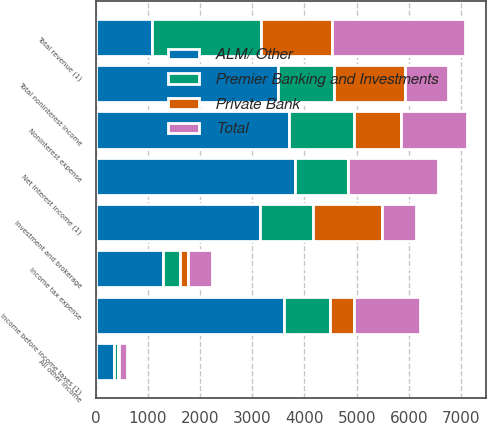Convert chart to OTSL. <chart><loc_0><loc_0><loc_500><loc_500><stacked_bar_chart><ecel><fcel>Net interest income (1)<fcel>Investment and brokerage<fcel>All other income<fcel>Total noninterest income<fcel>Total revenue (1)<fcel>Noninterest expense<fcel>Income before income taxes (1)<fcel>Income tax expense<nl><fcel>ALM/ Other<fcel>3820<fcel>3140<fcel>356<fcel>3496<fcel>1079<fcel>3710<fcel>3613<fcel>1297<nl><fcel>Premier Banking and Investments<fcel>1008<fcel>1014<fcel>65<fcel>1079<fcel>2087<fcel>1237<fcel>873<fcel>314<nl><fcel>Private Bank<fcel>6<fcel>1321<fcel>32<fcel>1353<fcel>1359<fcel>902<fcel>457<fcel>165<nl><fcel>Total<fcel>1732<fcel>670<fcel>148<fcel>818<fcel>2550<fcel>1266<fcel>1266<fcel>456<nl></chart> 